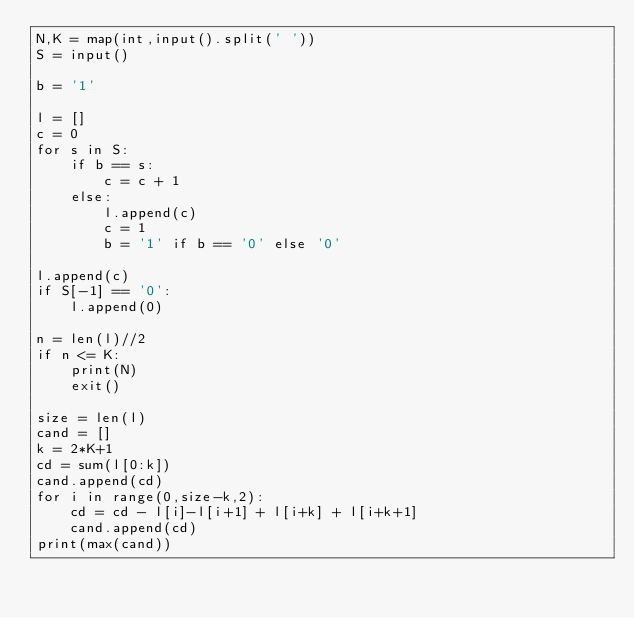Convert code to text. <code><loc_0><loc_0><loc_500><loc_500><_Python_>N,K = map(int,input().split(' '))
S = input()

b = '1'

l = []
c = 0
for s in S:
	if b == s:
		c = c + 1
	else:
		l.append(c)
		c = 1
		b = '1' if b == '0' else '0'

l.append(c)
if S[-1] == '0':
	l.append(0)

n = len(l)//2
if n <= K:
	print(N)
	exit()

size = len(l)
cand = []
k = 2*K+1
cd = sum(l[0:k])
cand.append(cd)
for i in range(0,size-k,2):
	cd = cd - l[i]-l[i+1] + l[i+k] + l[i+k+1]
	cand.append(cd)
print(max(cand))



</code> 